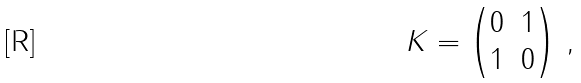Convert formula to latex. <formula><loc_0><loc_0><loc_500><loc_500>K = \begin{pmatrix} 0 & 1 \\ 1 & 0 \end{pmatrix} \, ,</formula> 